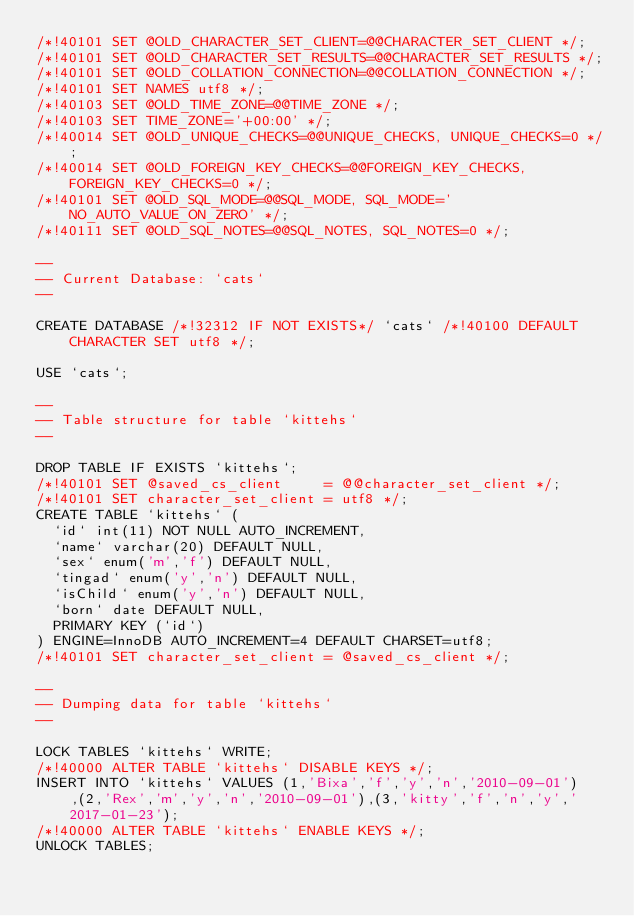<code> <loc_0><loc_0><loc_500><loc_500><_SQL_>/*!40101 SET @OLD_CHARACTER_SET_CLIENT=@@CHARACTER_SET_CLIENT */;
/*!40101 SET @OLD_CHARACTER_SET_RESULTS=@@CHARACTER_SET_RESULTS */;
/*!40101 SET @OLD_COLLATION_CONNECTION=@@COLLATION_CONNECTION */;
/*!40101 SET NAMES utf8 */;
/*!40103 SET @OLD_TIME_ZONE=@@TIME_ZONE */;
/*!40103 SET TIME_ZONE='+00:00' */;
/*!40014 SET @OLD_UNIQUE_CHECKS=@@UNIQUE_CHECKS, UNIQUE_CHECKS=0 */;
/*!40014 SET @OLD_FOREIGN_KEY_CHECKS=@@FOREIGN_KEY_CHECKS, FOREIGN_KEY_CHECKS=0 */;
/*!40101 SET @OLD_SQL_MODE=@@SQL_MODE, SQL_MODE='NO_AUTO_VALUE_ON_ZERO' */;
/*!40111 SET @OLD_SQL_NOTES=@@SQL_NOTES, SQL_NOTES=0 */;

--
-- Current Database: `cats`
--

CREATE DATABASE /*!32312 IF NOT EXISTS*/ `cats` /*!40100 DEFAULT CHARACTER SET utf8 */;

USE `cats`;

--
-- Table structure for table `kittehs`
--

DROP TABLE IF EXISTS `kittehs`;
/*!40101 SET @saved_cs_client     = @@character_set_client */;
/*!40101 SET character_set_client = utf8 */;
CREATE TABLE `kittehs` (
  `id` int(11) NOT NULL AUTO_INCREMENT,
  `name` varchar(20) DEFAULT NULL,
  `sex` enum('m','f') DEFAULT NULL,
  `tingad` enum('y','n') DEFAULT NULL,
  `isChild` enum('y','n') DEFAULT NULL,
  `born` date DEFAULT NULL,
  PRIMARY KEY (`id`)
) ENGINE=InnoDB AUTO_INCREMENT=4 DEFAULT CHARSET=utf8;
/*!40101 SET character_set_client = @saved_cs_client */;

--
-- Dumping data for table `kittehs`
--

LOCK TABLES `kittehs` WRITE;
/*!40000 ALTER TABLE `kittehs` DISABLE KEYS */;
INSERT INTO `kittehs` VALUES (1,'Bixa','f','y','n','2010-09-01'),(2,'Rex','m','y','n','2010-09-01'),(3,'kitty','f','n','y','2017-01-23');
/*!40000 ALTER TABLE `kittehs` ENABLE KEYS */;
UNLOCK TABLES;</code> 